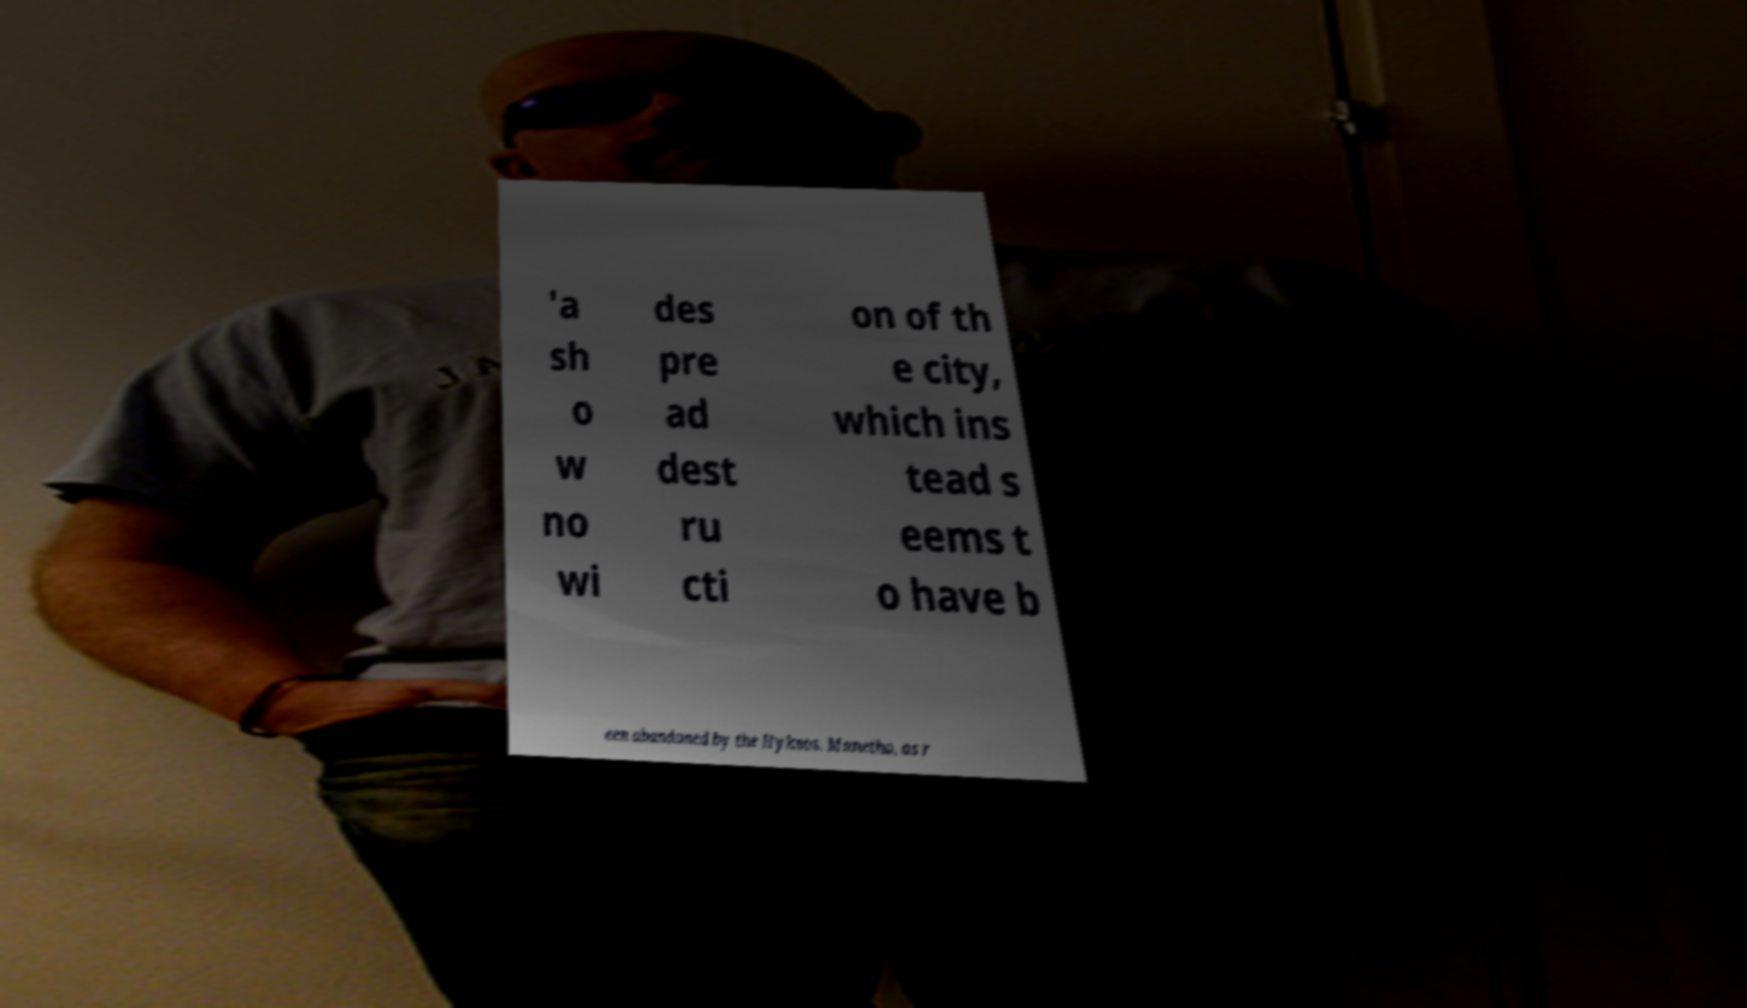Can you read and provide the text displayed in the image?This photo seems to have some interesting text. Can you extract and type it out for me? 'a sh o w no wi des pre ad dest ru cti on of th e city, which ins tead s eems t o have b een abandoned by the Hyksos. Manetho, as r 